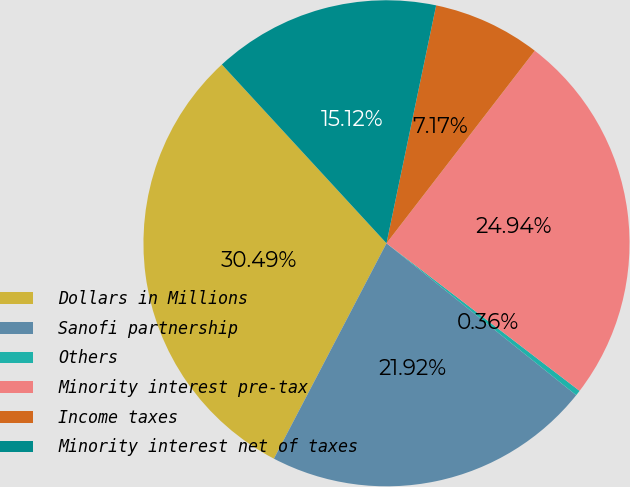Convert chart to OTSL. <chart><loc_0><loc_0><loc_500><loc_500><pie_chart><fcel>Dollars in Millions<fcel>Sanofi partnership<fcel>Others<fcel>Minority interest pre-tax<fcel>Income taxes<fcel>Minority interest net of taxes<nl><fcel>30.49%<fcel>21.92%<fcel>0.36%<fcel>24.94%<fcel>7.17%<fcel>15.12%<nl></chart> 